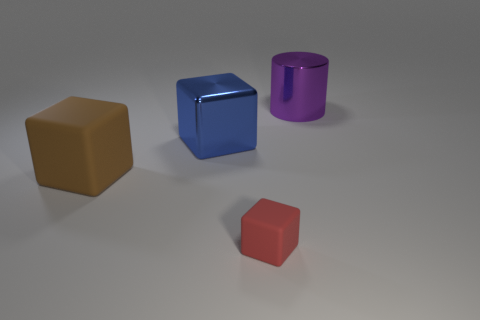Add 1 red objects. How many objects exist? 5 Subtract all cubes. How many objects are left? 1 Add 4 small rubber cubes. How many small rubber cubes are left? 5 Add 3 small rubber blocks. How many small rubber blocks exist? 4 Subtract 0 blue balls. How many objects are left? 4 Subtract all large cubes. Subtract all large blocks. How many objects are left? 0 